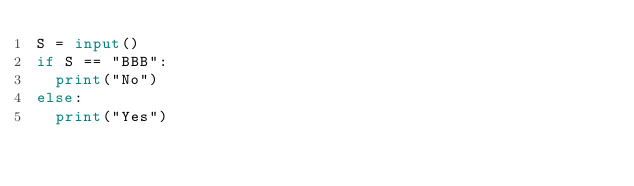<code> <loc_0><loc_0><loc_500><loc_500><_Python_>S = input()
if S == "BBB":
  print("No")
else:
  print("Yes")</code> 